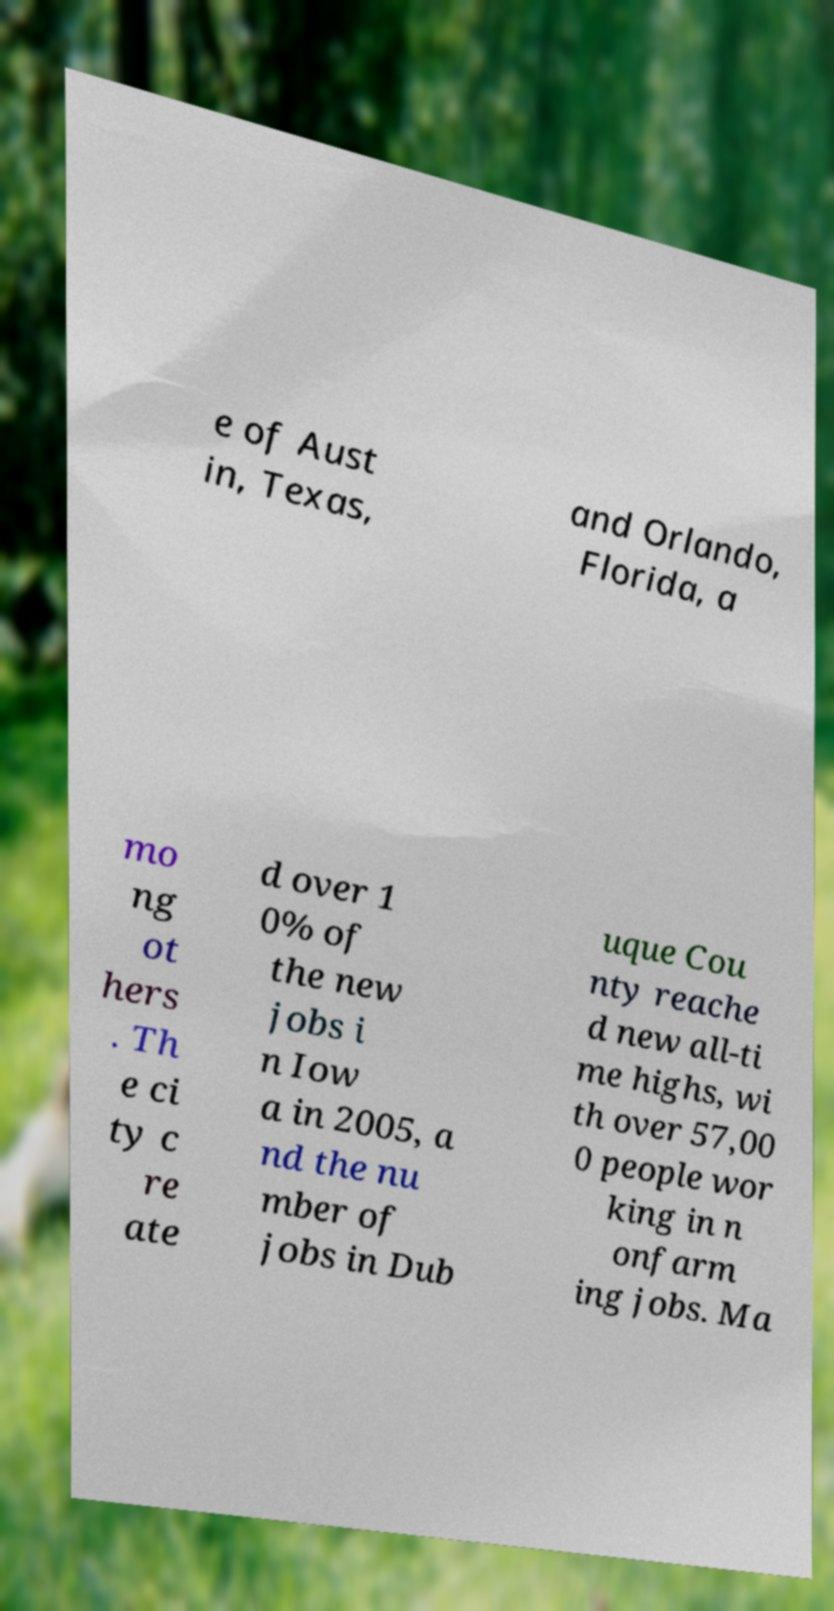For documentation purposes, I need the text within this image transcribed. Could you provide that? e of Aust in, Texas, and Orlando, Florida, a mo ng ot hers . Th e ci ty c re ate d over 1 0% of the new jobs i n Iow a in 2005, a nd the nu mber of jobs in Dub uque Cou nty reache d new all-ti me highs, wi th over 57,00 0 people wor king in n onfarm ing jobs. Ma 